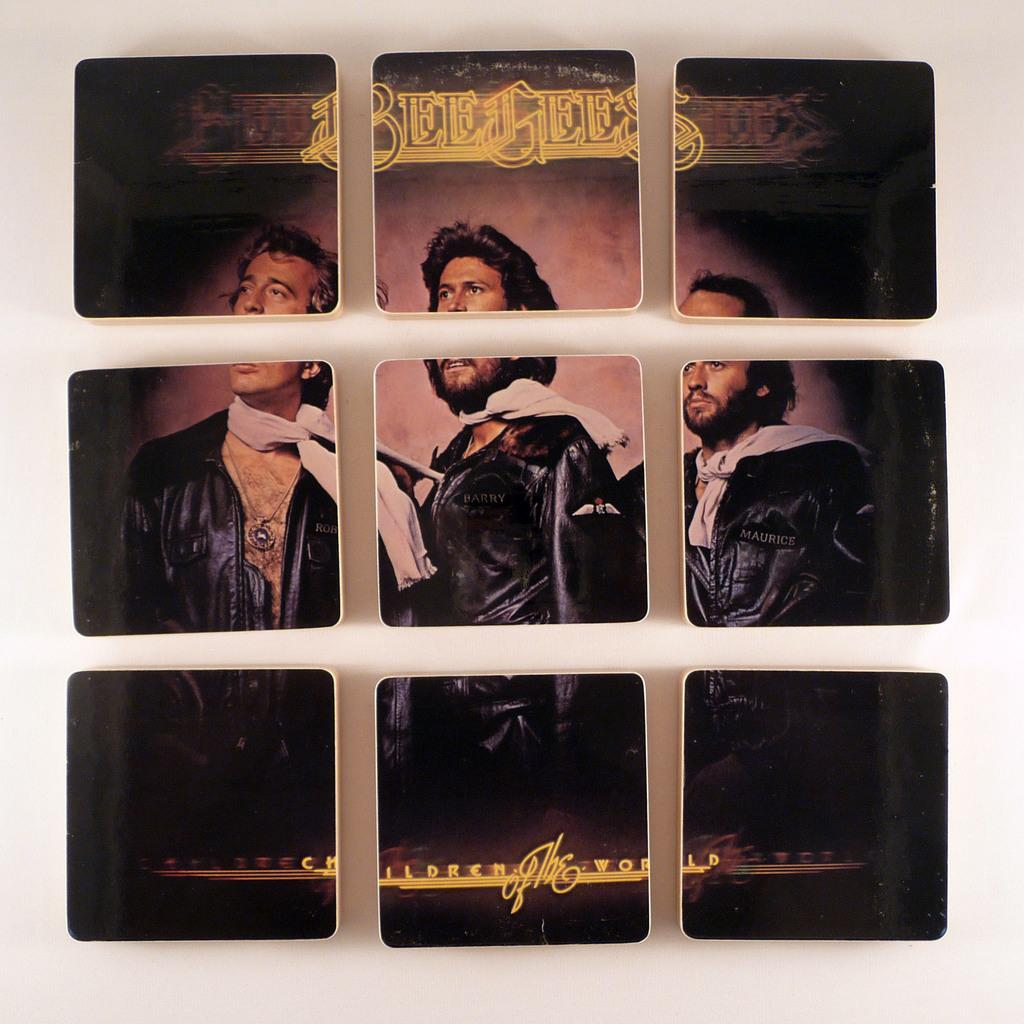What is featured on the poster in the image? The poster contains images of men. What else can be seen on the poster besides the images? There is text on the poster. Is there any architectural feature visible in the image? Yes, there is a window in the image. What is the purpose of the poster in the image? The purpose of the poster cannot be determined from the image alone, but it likely contains information or advertisements related to the images of men. What type of popcorn is being served to the mom in the image? There is no mom or popcorn present in the image; it only features a poster with images of men and text. 